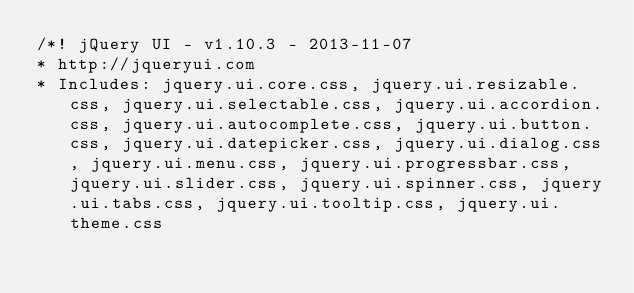Convert code to text. <code><loc_0><loc_0><loc_500><loc_500><_CSS_>/*! jQuery UI - v1.10.3 - 2013-11-07
* http://jqueryui.com
* Includes: jquery.ui.core.css, jquery.ui.resizable.css, jquery.ui.selectable.css, jquery.ui.accordion.css, jquery.ui.autocomplete.css, jquery.ui.button.css, jquery.ui.datepicker.css, jquery.ui.dialog.css, jquery.ui.menu.css, jquery.ui.progressbar.css, jquery.ui.slider.css, jquery.ui.spinner.css, jquery.ui.tabs.css, jquery.ui.tooltip.css, jquery.ui.theme.css</code> 